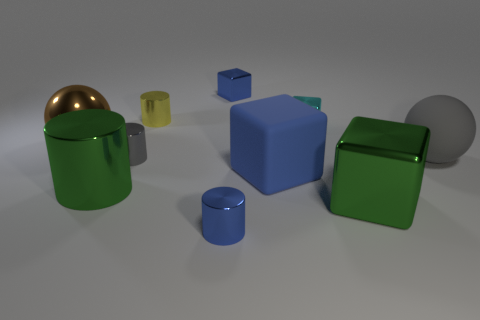Is the number of brown spheres that are right of the gray ball greater than the number of large brown metal balls? no 